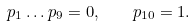Convert formula to latex. <formula><loc_0><loc_0><loc_500><loc_500>p _ { 1 } \dots p _ { 9 } = 0 , \quad p _ { 1 0 } = 1 .</formula> 